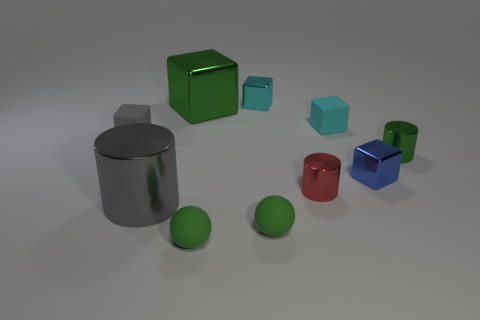What material is the tiny gray thing that is on the left side of the shiny cube that is in front of the tiny cyan matte thing?
Your answer should be very brief. Rubber. What number of other small gray matte objects are the same shape as the small gray matte thing?
Give a very brief answer. 0. Are there any shiny things of the same color as the large shiny block?
Provide a short and direct response. Yes. How many things are either small rubber blocks that are left of the big metallic cube or tiny things right of the tiny gray cube?
Offer a terse response. 8. Is there a small rubber block that is to the right of the big thing behind the tiny green metal object?
Your response must be concise. Yes. What is the shape of the gray matte thing that is the same size as the cyan matte thing?
Make the answer very short. Cube. What number of things are either tiny matte objects that are in front of the blue shiny object or brown cylinders?
Your response must be concise. 2. How many other things are there of the same material as the green cylinder?
Keep it short and to the point. 5. What shape is the small metal thing that is the same color as the big block?
Provide a succinct answer. Cylinder. What size is the green metal object behind the gray matte thing?
Make the answer very short. Large. 